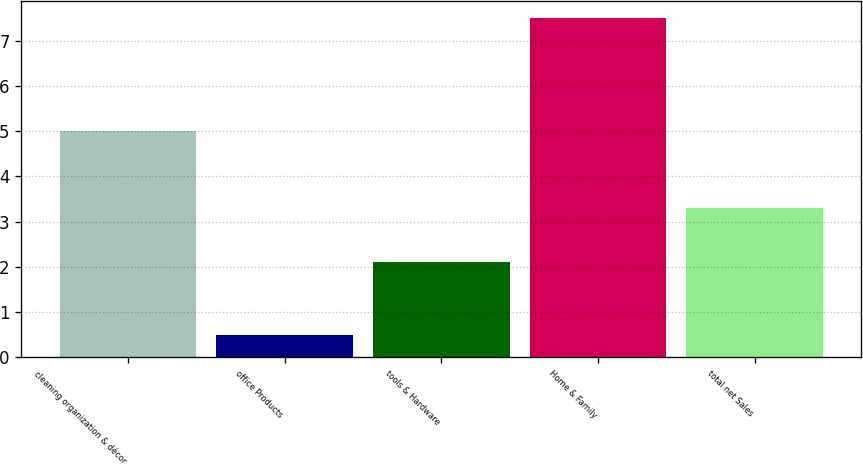<chart> <loc_0><loc_0><loc_500><loc_500><bar_chart><fcel>cleaning organization & décor<fcel>office Products<fcel>tools & Hardware<fcel>Home & Family<fcel>total net Sales<nl><fcel>5<fcel>0.5<fcel>2.1<fcel>7.5<fcel>3.3<nl></chart> 